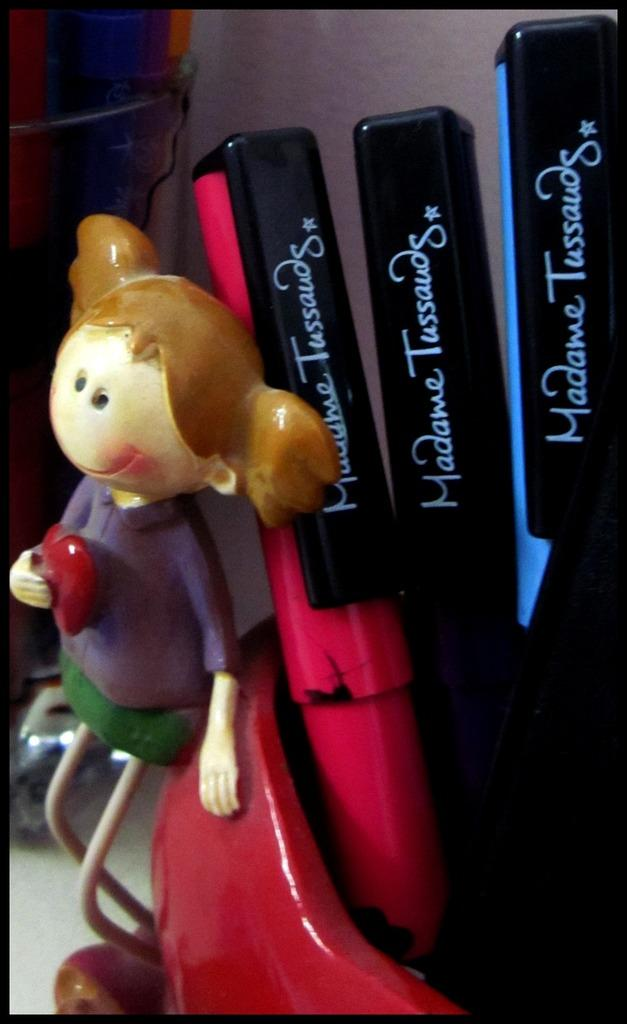<image>
Share a concise interpretation of the image provided. In a red container, items branded with the label of Madame Tussaud's are collected. 